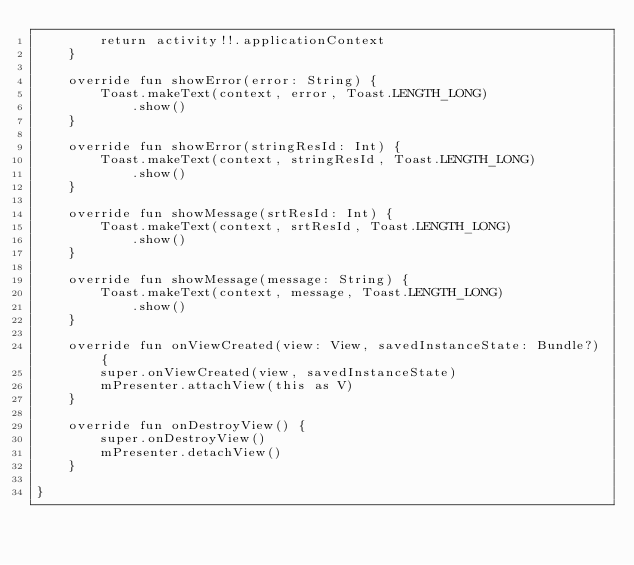<code> <loc_0><loc_0><loc_500><loc_500><_Kotlin_>        return activity!!.applicationContext
    }

    override fun showError(error: String) {
        Toast.makeText(context, error, Toast.LENGTH_LONG)
            .show()
    }

    override fun showError(stringResId: Int) {
        Toast.makeText(context, stringResId, Toast.LENGTH_LONG)
            .show()
    }

    override fun showMessage(srtResId: Int) {
        Toast.makeText(context, srtResId, Toast.LENGTH_LONG)
            .show()
    }

    override fun showMessage(message: String) {
        Toast.makeText(context, message, Toast.LENGTH_LONG)
            .show()
    }

    override fun onViewCreated(view: View, savedInstanceState: Bundle?) {
        super.onViewCreated(view, savedInstanceState)
        mPresenter.attachView(this as V)
    }

    override fun onDestroyView() {
        super.onDestroyView()
        mPresenter.detachView()
    }

}</code> 